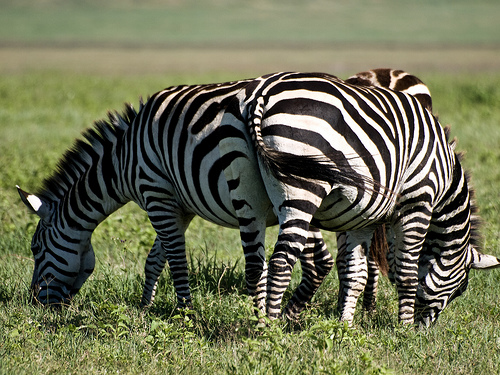What interactions can you observe between the zebras? The zebras seem to be engaged in communal grazing, a behavior common among these animals that fosters social bonding and collective vigilance for predators. 